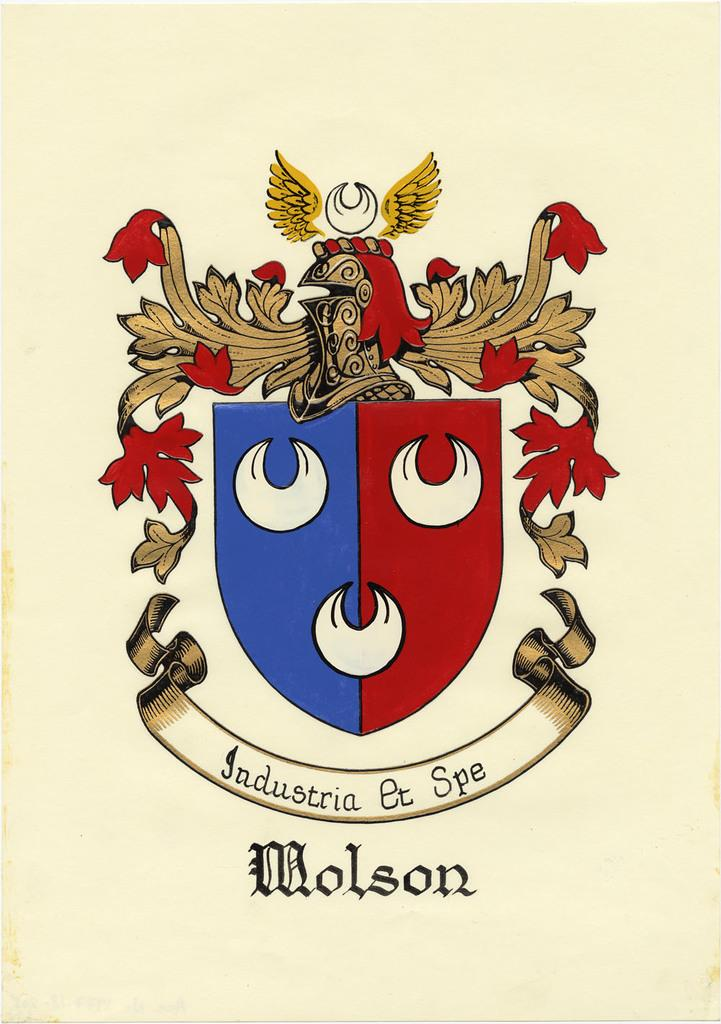<image>
Relay a brief, clear account of the picture shown. A crest is displayed in red, white and blue for Molson. 